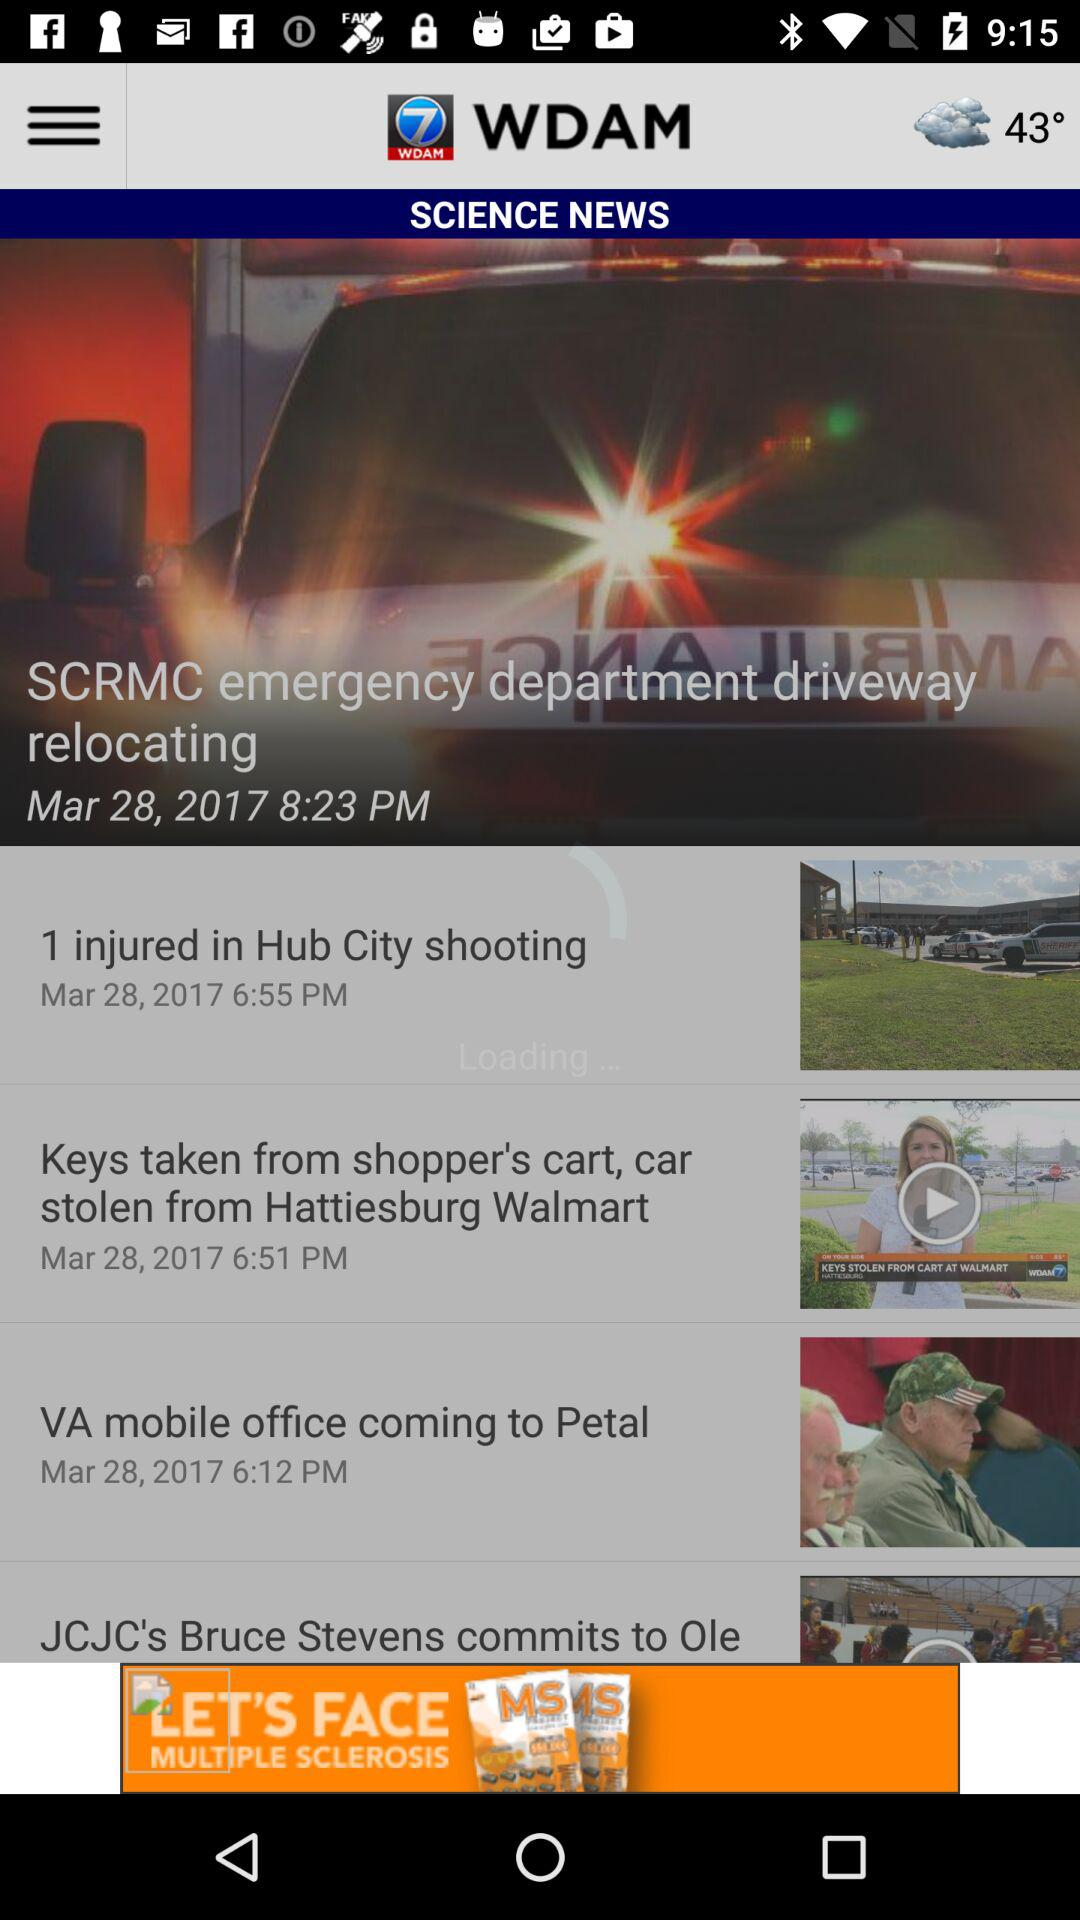How many news articles are there?
Answer the question using a single word or phrase. 4 